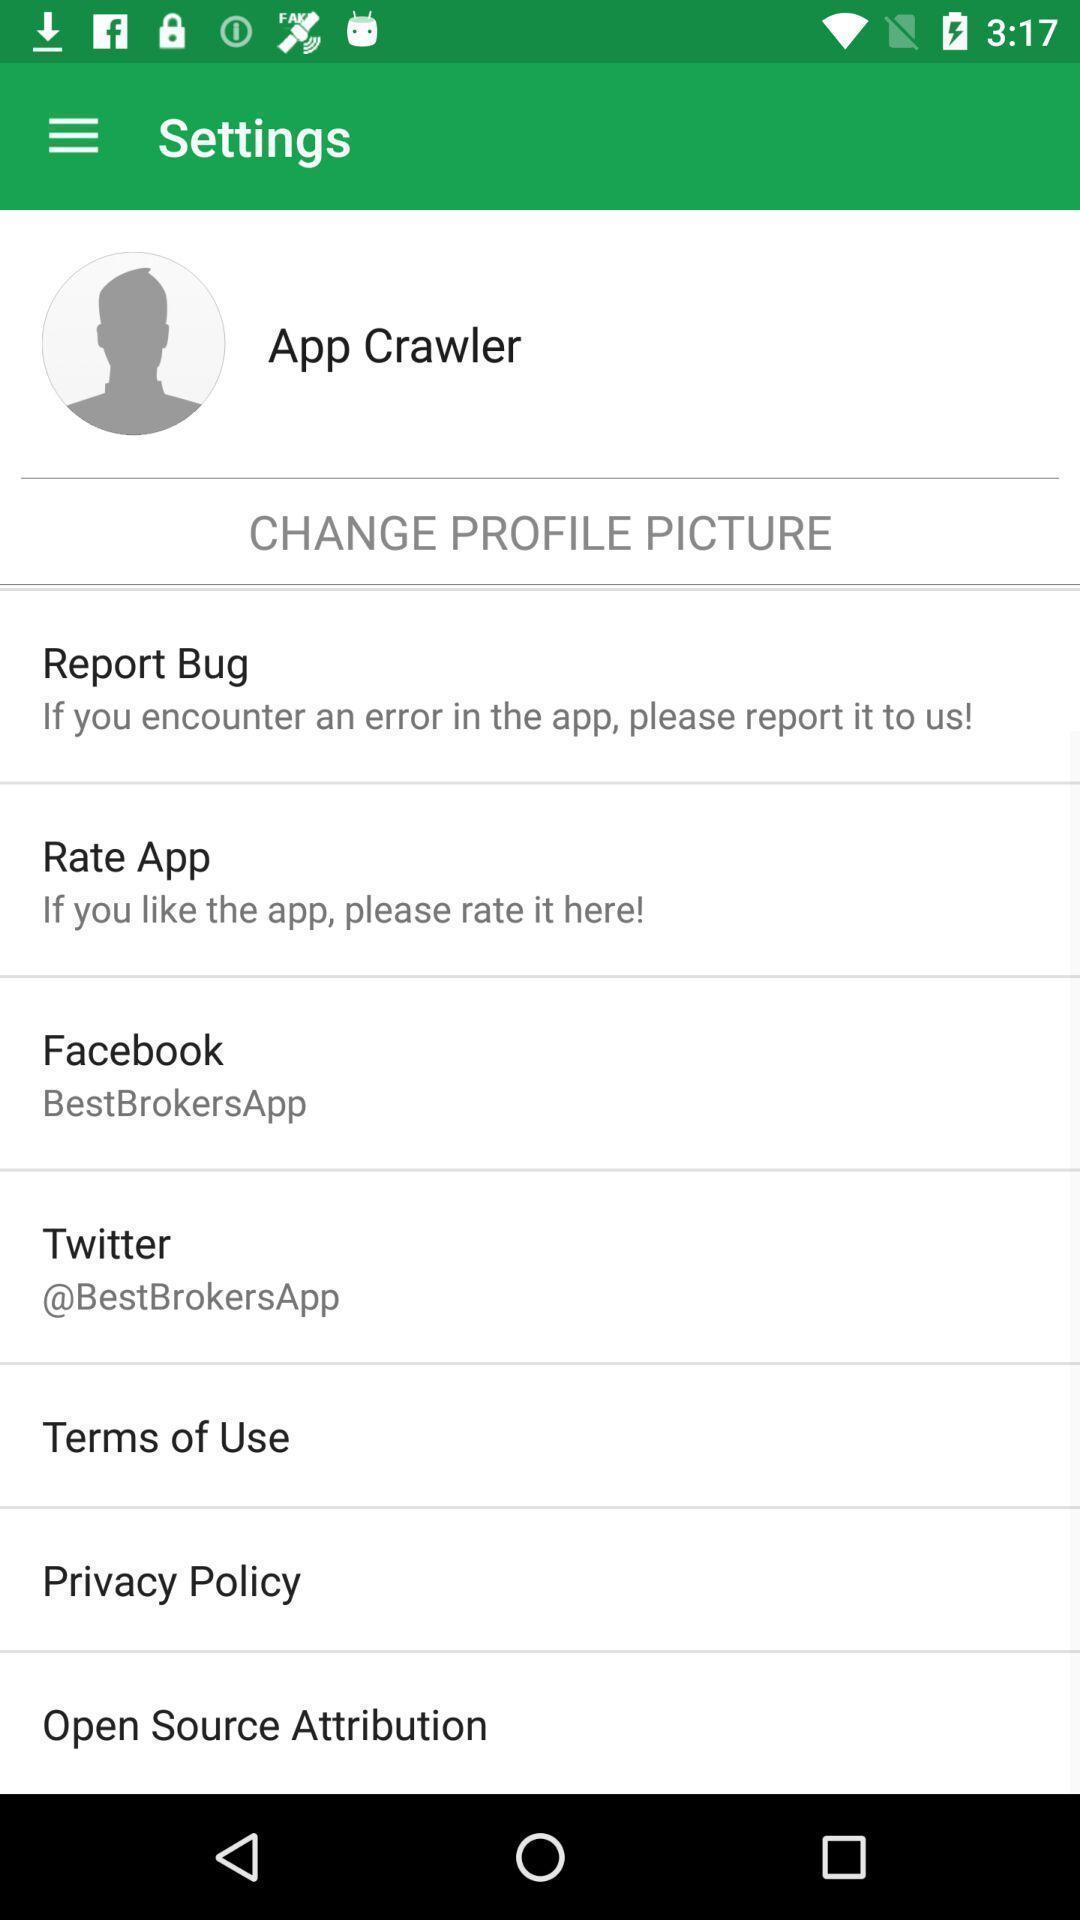Tell me about the visual elements in this screen capture. Settings page for a stocks related app. 